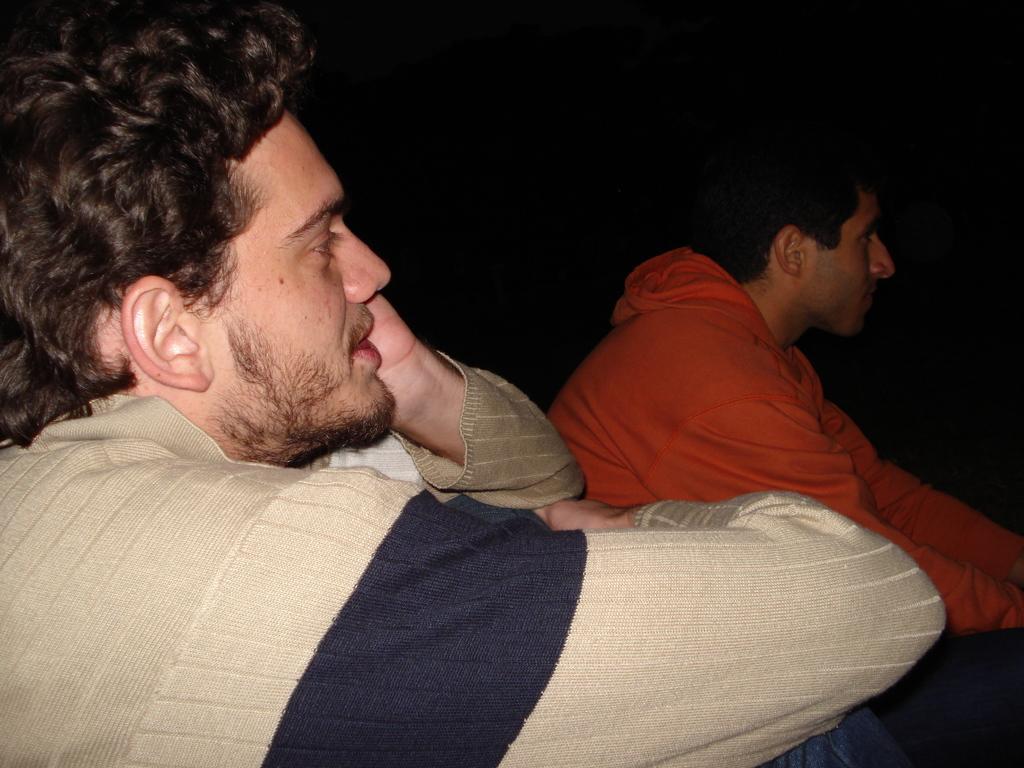Could you give a brief overview of what you see in this image? In this image I can see two men in the front. I can see one of them is wearing sweatshirt and another one is wearing orange colour hoodie. I can also see black colour in the background. 